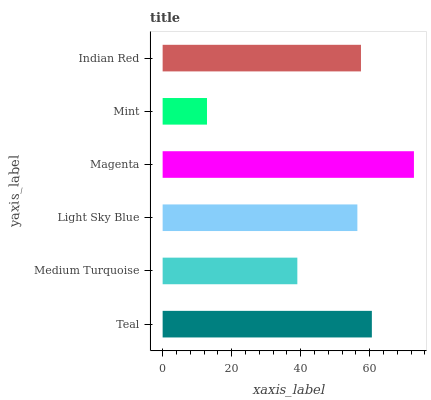Is Mint the minimum?
Answer yes or no. Yes. Is Magenta the maximum?
Answer yes or no. Yes. Is Medium Turquoise the minimum?
Answer yes or no. No. Is Medium Turquoise the maximum?
Answer yes or no. No. Is Teal greater than Medium Turquoise?
Answer yes or no. Yes. Is Medium Turquoise less than Teal?
Answer yes or no. Yes. Is Medium Turquoise greater than Teal?
Answer yes or no. No. Is Teal less than Medium Turquoise?
Answer yes or no. No. Is Indian Red the high median?
Answer yes or no. Yes. Is Light Sky Blue the low median?
Answer yes or no. Yes. Is Magenta the high median?
Answer yes or no. No. Is Mint the low median?
Answer yes or no. No. 